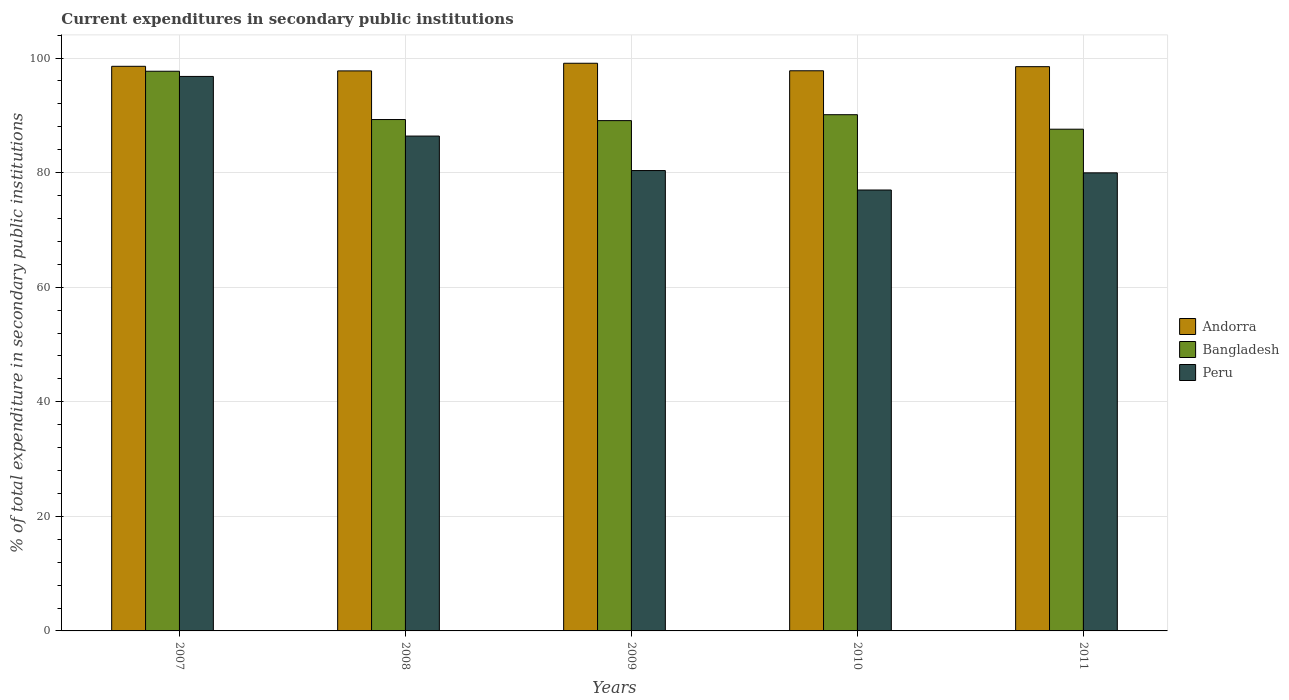How many different coloured bars are there?
Provide a succinct answer. 3. How many groups of bars are there?
Your answer should be very brief. 5. Are the number of bars per tick equal to the number of legend labels?
Provide a succinct answer. Yes. What is the current expenditures in secondary public institutions in Andorra in 2008?
Offer a terse response. 97.76. Across all years, what is the maximum current expenditures in secondary public institutions in Andorra?
Your response must be concise. 99.09. Across all years, what is the minimum current expenditures in secondary public institutions in Bangladesh?
Provide a short and direct response. 87.58. In which year was the current expenditures in secondary public institutions in Peru minimum?
Ensure brevity in your answer.  2010. What is the total current expenditures in secondary public institutions in Andorra in the graph?
Make the answer very short. 491.67. What is the difference between the current expenditures in secondary public institutions in Bangladesh in 2007 and that in 2011?
Keep it short and to the point. 10.11. What is the difference between the current expenditures in secondary public institutions in Peru in 2007 and the current expenditures in secondary public institutions in Bangladesh in 2008?
Keep it short and to the point. 7.52. What is the average current expenditures in secondary public institutions in Peru per year?
Give a very brief answer. 84.09. In the year 2009, what is the difference between the current expenditures in secondary public institutions in Andorra and current expenditures in secondary public institutions in Bangladesh?
Keep it short and to the point. 10.01. What is the ratio of the current expenditures in secondary public institutions in Andorra in 2008 to that in 2010?
Give a very brief answer. 1. Is the current expenditures in secondary public institutions in Andorra in 2007 less than that in 2010?
Provide a short and direct response. No. What is the difference between the highest and the second highest current expenditures in secondary public institutions in Bangladesh?
Give a very brief answer. 7.58. What is the difference between the highest and the lowest current expenditures in secondary public institutions in Peru?
Offer a terse response. 19.82. In how many years, is the current expenditures in secondary public institutions in Bangladesh greater than the average current expenditures in secondary public institutions in Bangladesh taken over all years?
Your answer should be very brief. 1. Is the sum of the current expenditures in secondary public institutions in Peru in 2009 and 2010 greater than the maximum current expenditures in secondary public institutions in Andorra across all years?
Your response must be concise. Yes. What does the 3rd bar from the left in 2007 represents?
Your answer should be compact. Peru. What does the 3rd bar from the right in 2011 represents?
Your answer should be very brief. Andorra. Is it the case that in every year, the sum of the current expenditures in secondary public institutions in Andorra and current expenditures in secondary public institutions in Bangladesh is greater than the current expenditures in secondary public institutions in Peru?
Your answer should be very brief. Yes. How many bars are there?
Ensure brevity in your answer.  15. How many years are there in the graph?
Ensure brevity in your answer.  5. What is the difference between two consecutive major ticks on the Y-axis?
Provide a short and direct response. 20. Are the values on the major ticks of Y-axis written in scientific E-notation?
Offer a very short reply. No. Where does the legend appear in the graph?
Make the answer very short. Center right. How many legend labels are there?
Your response must be concise. 3. What is the title of the graph?
Keep it short and to the point. Current expenditures in secondary public institutions. What is the label or title of the X-axis?
Your response must be concise. Years. What is the label or title of the Y-axis?
Offer a very short reply. % of total expenditure in secondary public institutions. What is the % of total expenditure in secondary public institutions of Andorra in 2007?
Your answer should be compact. 98.56. What is the % of total expenditure in secondary public institutions of Bangladesh in 2007?
Give a very brief answer. 97.69. What is the % of total expenditure in secondary public institutions of Peru in 2007?
Provide a succinct answer. 96.79. What is the % of total expenditure in secondary public institutions in Andorra in 2008?
Provide a short and direct response. 97.76. What is the % of total expenditure in secondary public institutions of Bangladesh in 2008?
Provide a short and direct response. 89.26. What is the % of total expenditure in secondary public institutions in Peru in 2008?
Give a very brief answer. 86.38. What is the % of total expenditure in secondary public institutions of Andorra in 2009?
Keep it short and to the point. 99.09. What is the % of total expenditure in secondary public institutions of Bangladesh in 2009?
Your answer should be very brief. 89.08. What is the % of total expenditure in secondary public institutions in Peru in 2009?
Offer a terse response. 80.36. What is the % of total expenditure in secondary public institutions of Andorra in 2010?
Make the answer very short. 97.78. What is the % of total expenditure in secondary public institutions in Bangladesh in 2010?
Give a very brief answer. 90.11. What is the % of total expenditure in secondary public institutions in Peru in 2010?
Your answer should be compact. 76.97. What is the % of total expenditure in secondary public institutions in Andorra in 2011?
Ensure brevity in your answer.  98.49. What is the % of total expenditure in secondary public institutions of Bangladesh in 2011?
Your answer should be compact. 87.58. What is the % of total expenditure in secondary public institutions in Peru in 2011?
Make the answer very short. 79.96. Across all years, what is the maximum % of total expenditure in secondary public institutions of Andorra?
Your answer should be very brief. 99.09. Across all years, what is the maximum % of total expenditure in secondary public institutions of Bangladesh?
Your answer should be compact. 97.69. Across all years, what is the maximum % of total expenditure in secondary public institutions in Peru?
Your answer should be very brief. 96.79. Across all years, what is the minimum % of total expenditure in secondary public institutions in Andorra?
Your answer should be very brief. 97.76. Across all years, what is the minimum % of total expenditure in secondary public institutions of Bangladesh?
Offer a terse response. 87.58. Across all years, what is the minimum % of total expenditure in secondary public institutions of Peru?
Ensure brevity in your answer.  76.97. What is the total % of total expenditure in secondary public institutions in Andorra in the graph?
Ensure brevity in your answer.  491.67. What is the total % of total expenditure in secondary public institutions in Bangladesh in the graph?
Ensure brevity in your answer.  453.73. What is the total % of total expenditure in secondary public institutions in Peru in the graph?
Your response must be concise. 420.45. What is the difference between the % of total expenditure in secondary public institutions of Andorra in 2007 and that in 2008?
Your answer should be compact. 0.8. What is the difference between the % of total expenditure in secondary public institutions in Bangladesh in 2007 and that in 2008?
Provide a succinct answer. 8.43. What is the difference between the % of total expenditure in secondary public institutions of Peru in 2007 and that in 2008?
Your answer should be very brief. 10.41. What is the difference between the % of total expenditure in secondary public institutions in Andorra in 2007 and that in 2009?
Your response must be concise. -0.53. What is the difference between the % of total expenditure in secondary public institutions in Bangladesh in 2007 and that in 2009?
Make the answer very short. 8.62. What is the difference between the % of total expenditure in secondary public institutions in Peru in 2007 and that in 2009?
Ensure brevity in your answer.  16.43. What is the difference between the % of total expenditure in secondary public institutions in Andorra in 2007 and that in 2010?
Provide a succinct answer. 0.78. What is the difference between the % of total expenditure in secondary public institutions in Bangladesh in 2007 and that in 2010?
Your answer should be compact. 7.58. What is the difference between the % of total expenditure in secondary public institutions of Peru in 2007 and that in 2010?
Your answer should be compact. 19.82. What is the difference between the % of total expenditure in secondary public institutions in Andorra in 2007 and that in 2011?
Provide a short and direct response. 0.06. What is the difference between the % of total expenditure in secondary public institutions of Bangladesh in 2007 and that in 2011?
Keep it short and to the point. 10.11. What is the difference between the % of total expenditure in secondary public institutions of Peru in 2007 and that in 2011?
Give a very brief answer. 16.83. What is the difference between the % of total expenditure in secondary public institutions in Andorra in 2008 and that in 2009?
Provide a succinct answer. -1.33. What is the difference between the % of total expenditure in secondary public institutions in Bangladesh in 2008 and that in 2009?
Provide a short and direct response. 0.19. What is the difference between the % of total expenditure in secondary public institutions in Peru in 2008 and that in 2009?
Make the answer very short. 6.02. What is the difference between the % of total expenditure in secondary public institutions of Andorra in 2008 and that in 2010?
Ensure brevity in your answer.  -0.02. What is the difference between the % of total expenditure in secondary public institutions of Bangladesh in 2008 and that in 2010?
Offer a very short reply. -0.84. What is the difference between the % of total expenditure in secondary public institutions of Peru in 2008 and that in 2010?
Keep it short and to the point. 9.41. What is the difference between the % of total expenditure in secondary public institutions in Andorra in 2008 and that in 2011?
Give a very brief answer. -0.74. What is the difference between the % of total expenditure in secondary public institutions in Bangladesh in 2008 and that in 2011?
Ensure brevity in your answer.  1.68. What is the difference between the % of total expenditure in secondary public institutions of Peru in 2008 and that in 2011?
Provide a short and direct response. 6.42. What is the difference between the % of total expenditure in secondary public institutions of Andorra in 2009 and that in 2010?
Offer a very short reply. 1.31. What is the difference between the % of total expenditure in secondary public institutions of Bangladesh in 2009 and that in 2010?
Keep it short and to the point. -1.03. What is the difference between the % of total expenditure in secondary public institutions in Peru in 2009 and that in 2010?
Your response must be concise. 3.4. What is the difference between the % of total expenditure in secondary public institutions in Andorra in 2009 and that in 2011?
Provide a succinct answer. 0.6. What is the difference between the % of total expenditure in secondary public institutions in Bangladesh in 2009 and that in 2011?
Keep it short and to the point. 1.5. What is the difference between the % of total expenditure in secondary public institutions of Peru in 2009 and that in 2011?
Provide a short and direct response. 0.4. What is the difference between the % of total expenditure in secondary public institutions of Andorra in 2010 and that in 2011?
Your answer should be very brief. -0.72. What is the difference between the % of total expenditure in secondary public institutions of Bangladesh in 2010 and that in 2011?
Offer a very short reply. 2.53. What is the difference between the % of total expenditure in secondary public institutions of Peru in 2010 and that in 2011?
Offer a very short reply. -2.99. What is the difference between the % of total expenditure in secondary public institutions of Andorra in 2007 and the % of total expenditure in secondary public institutions of Bangladesh in 2008?
Provide a succinct answer. 9.29. What is the difference between the % of total expenditure in secondary public institutions of Andorra in 2007 and the % of total expenditure in secondary public institutions of Peru in 2008?
Your answer should be very brief. 12.18. What is the difference between the % of total expenditure in secondary public institutions in Bangladesh in 2007 and the % of total expenditure in secondary public institutions in Peru in 2008?
Your answer should be compact. 11.32. What is the difference between the % of total expenditure in secondary public institutions of Andorra in 2007 and the % of total expenditure in secondary public institutions of Bangladesh in 2009?
Make the answer very short. 9.48. What is the difference between the % of total expenditure in secondary public institutions in Andorra in 2007 and the % of total expenditure in secondary public institutions in Peru in 2009?
Offer a very short reply. 18.2. What is the difference between the % of total expenditure in secondary public institutions in Bangladesh in 2007 and the % of total expenditure in secondary public institutions in Peru in 2009?
Keep it short and to the point. 17.33. What is the difference between the % of total expenditure in secondary public institutions of Andorra in 2007 and the % of total expenditure in secondary public institutions of Bangladesh in 2010?
Give a very brief answer. 8.45. What is the difference between the % of total expenditure in secondary public institutions in Andorra in 2007 and the % of total expenditure in secondary public institutions in Peru in 2010?
Provide a succinct answer. 21.59. What is the difference between the % of total expenditure in secondary public institutions in Bangladesh in 2007 and the % of total expenditure in secondary public institutions in Peru in 2010?
Offer a terse response. 20.73. What is the difference between the % of total expenditure in secondary public institutions in Andorra in 2007 and the % of total expenditure in secondary public institutions in Bangladesh in 2011?
Your response must be concise. 10.98. What is the difference between the % of total expenditure in secondary public institutions of Andorra in 2007 and the % of total expenditure in secondary public institutions of Peru in 2011?
Your answer should be very brief. 18.6. What is the difference between the % of total expenditure in secondary public institutions of Bangladesh in 2007 and the % of total expenditure in secondary public institutions of Peru in 2011?
Offer a terse response. 17.74. What is the difference between the % of total expenditure in secondary public institutions in Andorra in 2008 and the % of total expenditure in secondary public institutions in Bangladesh in 2009?
Your response must be concise. 8.68. What is the difference between the % of total expenditure in secondary public institutions of Andorra in 2008 and the % of total expenditure in secondary public institutions of Peru in 2009?
Provide a short and direct response. 17.4. What is the difference between the % of total expenditure in secondary public institutions in Bangladesh in 2008 and the % of total expenditure in secondary public institutions in Peru in 2009?
Make the answer very short. 8.9. What is the difference between the % of total expenditure in secondary public institutions in Andorra in 2008 and the % of total expenditure in secondary public institutions in Bangladesh in 2010?
Ensure brevity in your answer.  7.65. What is the difference between the % of total expenditure in secondary public institutions in Andorra in 2008 and the % of total expenditure in secondary public institutions in Peru in 2010?
Keep it short and to the point. 20.79. What is the difference between the % of total expenditure in secondary public institutions of Bangladesh in 2008 and the % of total expenditure in secondary public institutions of Peru in 2010?
Your response must be concise. 12.3. What is the difference between the % of total expenditure in secondary public institutions of Andorra in 2008 and the % of total expenditure in secondary public institutions of Bangladesh in 2011?
Keep it short and to the point. 10.18. What is the difference between the % of total expenditure in secondary public institutions of Andorra in 2008 and the % of total expenditure in secondary public institutions of Peru in 2011?
Make the answer very short. 17.8. What is the difference between the % of total expenditure in secondary public institutions in Bangladesh in 2008 and the % of total expenditure in secondary public institutions in Peru in 2011?
Offer a terse response. 9.31. What is the difference between the % of total expenditure in secondary public institutions in Andorra in 2009 and the % of total expenditure in secondary public institutions in Bangladesh in 2010?
Keep it short and to the point. 8.98. What is the difference between the % of total expenditure in secondary public institutions in Andorra in 2009 and the % of total expenditure in secondary public institutions in Peru in 2010?
Your answer should be compact. 22.12. What is the difference between the % of total expenditure in secondary public institutions of Bangladesh in 2009 and the % of total expenditure in secondary public institutions of Peru in 2010?
Your answer should be very brief. 12.11. What is the difference between the % of total expenditure in secondary public institutions in Andorra in 2009 and the % of total expenditure in secondary public institutions in Bangladesh in 2011?
Offer a terse response. 11.51. What is the difference between the % of total expenditure in secondary public institutions in Andorra in 2009 and the % of total expenditure in secondary public institutions in Peru in 2011?
Keep it short and to the point. 19.13. What is the difference between the % of total expenditure in secondary public institutions of Bangladesh in 2009 and the % of total expenditure in secondary public institutions of Peru in 2011?
Your answer should be compact. 9.12. What is the difference between the % of total expenditure in secondary public institutions in Andorra in 2010 and the % of total expenditure in secondary public institutions in Bangladesh in 2011?
Offer a very short reply. 10.2. What is the difference between the % of total expenditure in secondary public institutions in Andorra in 2010 and the % of total expenditure in secondary public institutions in Peru in 2011?
Offer a very short reply. 17.82. What is the difference between the % of total expenditure in secondary public institutions in Bangladesh in 2010 and the % of total expenditure in secondary public institutions in Peru in 2011?
Give a very brief answer. 10.15. What is the average % of total expenditure in secondary public institutions in Andorra per year?
Make the answer very short. 98.33. What is the average % of total expenditure in secondary public institutions of Bangladesh per year?
Provide a succinct answer. 90.75. What is the average % of total expenditure in secondary public institutions of Peru per year?
Keep it short and to the point. 84.09. In the year 2007, what is the difference between the % of total expenditure in secondary public institutions of Andorra and % of total expenditure in secondary public institutions of Bangladesh?
Provide a succinct answer. 0.86. In the year 2007, what is the difference between the % of total expenditure in secondary public institutions in Andorra and % of total expenditure in secondary public institutions in Peru?
Your answer should be very brief. 1.77. In the year 2007, what is the difference between the % of total expenditure in secondary public institutions in Bangladesh and % of total expenditure in secondary public institutions in Peru?
Offer a terse response. 0.9. In the year 2008, what is the difference between the % of total expenditure in secondary public institutions of Andorra and % of total expenditure in secondary public institutions of Bangladesh?
Your response must be concise. 8.49. In the year 2008, what is the difference between the % of total expenditure in secondary public institutions in Andorra and % of total expenditure in secondary public institutions in Peru?
Make the answer very short. 11.38. In the year 2008, what is the difference between the % of total expenditure in secondary public institutions of Bangladesh and % of total expenditure in secondary public institutions of Peru?
Your response must be concise. 2.89. In the year 2009, what is the difference between the % of total expenditure in secondary public institutions of Andorra and % of total expenditure in secondary public institutions of Bangladesh?
Provide a succinct answer. 10.01. In the year 2009, what is the difference between the % of total expenditure in secondary public institutions of Andorra and % of total expenditure in secondary public institutions of Peru?
Your response must be concise. 18.73. In the year 2009, what is the difference between the % of total expenditure in secondary public institutions of Bangladesh and % of total expenditure in secondary public institutions of Peru?
Offer a very short reply. 8.72. In the year 2010, what is the difference between the % of total expenditure in secondary public institutions in Andorra and % of total expenditure in secondary public institutions in Bangladesh?
Your answer should be compact. 7.67. In the year 2010, what is the difference between the % of total expenditure in secondary public institutions of Andorra and % of total expenditure in secondary public institutions of Peru?
Offer a terse response. 20.81. In the year 2010, what is the difference between the % of total expenditure in secondary public institutions of Bangladesh and % of total expenditure in secondary public institutions of Peru?
Offer a very short reply. 13.14. In the year 2011, what is the difference between the % of total expenditure in secondary public institutions of Andorra and % of total expenditure in secondary public institutions of Bangladesh?
Offer a terse response. 10.91. In the year 2011, what is the difference between the % of total expenditure in secondary public institutions in Andorra and % of total expenditure in secondary public institutions in Peru?
Offer a very short reply. 18.53. In the year 2011, what is the difference between the % of total expenditure in secondary public institutions of Bangladesh and % of total expenditure in secondary public institutions of Peru?
Your answer should be compact. 7.62. What is the ratio of the % of total expenditure in secondary public institutions of Andorra in 2007 to that in 2008?
Provide a succinct answer. 1.01. What is the ratio of the % of total expenditure in secondary public institutions in Bangladesh in 2007 to that in 2008?
Your response must be concise. 1.09. What is the ratio of the % of total expenditure in secondary public institutions in Peru in 2007 to that in 2008?
Give a very brief answer. 1.12. What is the ratio of the % of total expenditure in secondary public institutions in Andorra in 2007 to that in 2009?
Your answer should be compact. 0.99. What is the ratio of the % of total expenditure in secondary public institutions of Bangladesh in 2007 to that in 2009?
Give a very brief answer. 1.1. What is the ratio of the % of total expenditure in secondary public institutions in Peru in 2007 to that in 2009?
Offer a very short reply. 1.2. What is the ratio of the % of total expenditure in secondary public institutions in Bangladesh in 2007 to that in 2010?
Offer a terse response. 1.08. What is the ratio of the % of total expenditure in secondary public institutions in Peru in 2007 to that in 2010?
Keep it short and to the point. 1.26. What is the ratio of the % of total expenditure in secondary public institutions in Andorra in 2007 to that in 2011?
Provide a succinct answer. 1. What is the ratio of the % of total expenditure in secondary public institutions of Bangladesh in 2007 to that in 2011?
Your answer should be compact. 1.12. What is the ratio of the % of total expenditure in secondary public institutions of Peru in 2007 to that in 2011?
Ensure brevity in your answer.  1.21. What is the ratio of the % of total expenditure in secondary public institutions of Andorra in 2008 to that in 2009?
Keep it short and to the point. 0.99. What is the ratio of the % of total expenditure in secondary public institutions of Peru in 2008 to that in 2009?
Your answer should be very brief. 1.07. What is the ratio of the % of total expenditure in secondary public institutions of Bangladesh in 2008 to that in 2010?
Provide a short and direct response. 0.99. What is the ratio of the % of total expenditure in secondary public institutions of Peru in 2008 to that in 2010?
Offer a terse response. 1.12. What is the ratio of the % of total expenditure in secondary public institutions of Bangladesh in 2008 to that in 2011?
Your answer should be compact. 1.02. What is the ratio of the % of total expenditure in secondary public institutions in Peru in 2008 to that in 2011?
Your answer should be compact. 1.08. What is the ratio of the % of total expenditure in secondary public institutions of Andorra in 2009 to that in 2010?
Ensure brevity in your answer.  1.01. What is the ratio of the % of total expenditure in secondary public institutions in Bangladesh in 2009 to that in 2010?
Offer a very short reply. 0.99. What is the ratio of the % of total expenditure in secondary public institutions of Peru in 2009 to that in 2010?
Offer a terse response. 1.04. What is the ratio of the % of total expenditure in secondary public institutions in Andorra in 2009 to that in 2011?
Give a very brief answer. 1.01. What is the ratio of the % of total expenditure in secondary public institutions of Bangladesh in 2009 to that in 2011?
Your answer should be very brief. 1.02. What is the ratio of the % of total expenditure in secondary public institutions in Peru in 2009 to that in 2011?
Your answer should be compact. 1. What is the ratio of the % of total expenditure in secondary public institutions in Bangladesh in 2010 to that in 2011?
Keep it short and to the point. 1.03. What is the ratio of the % of total expenditure in secondary public institutions in Peru in 2010 to that in 2011?
Your answer should be very brief. 0.96. What is the difference between the highest and the second highest % of total expenditure in secondary public institutions of Andorra?
Your response must be concise. 0.53. What is the difference between the highest and the second highest % of total expenditure in secondary public institutions of Bangladesh?
Provide a short and direct response. 7.58. What is the difference between the highest and the second highest % of total expenditure in secondary public institutions of Peru?
Your response must be concise. 10.41. What is the difference between the highest and the lowest % of total expenditure in secondary public institutions of Andorra?
Provide a succinct answer. 1.33. What is the difference between the highest and the lowest % of total expenditure in secondary public institutions in Bangladesh?
Your answer should be compact. 10.11. What is the difference between the highest and the lowest % of total expenditure in secondary public institutions in Peru?
Make the answer very short. 19.82. 